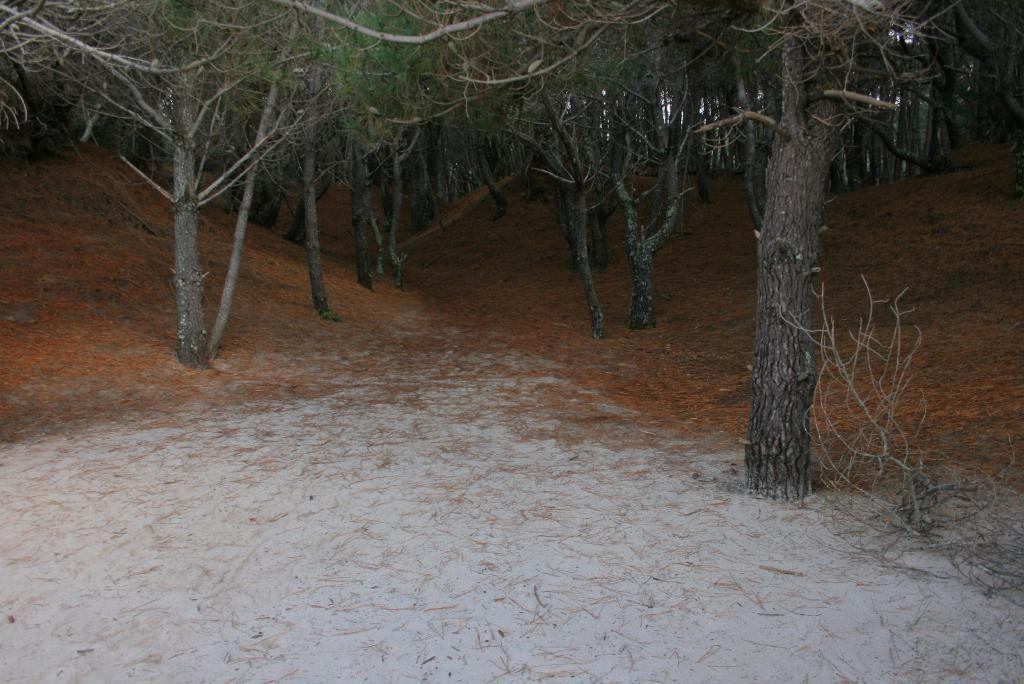What type of vegetation can be seen in the image? There are trees and plants in the image. What is the condition of the leaves on the ground in the image? Dried leaves are present on the land in the image. What type of government is depicted in the image? There is no government depicted in the image; it features trees, plants, and dried leaves on the ground. Can you see anyone swimming in the image? There is no swimming or water visible in the image; it features trees, plants, and dried leaves on the ground. 